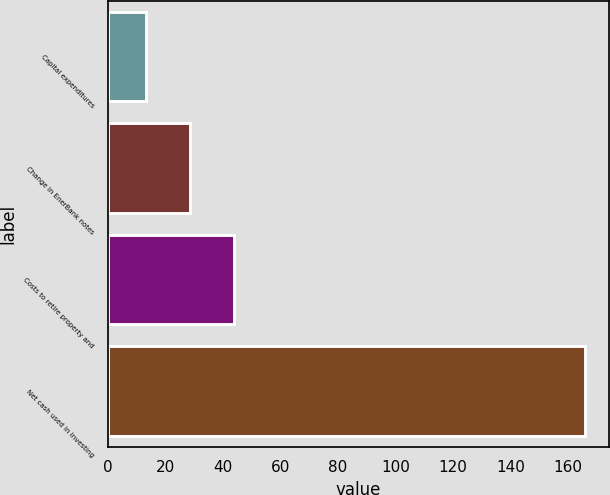Convert chart to OTSL. <chart><loc_0><loc_0><loc_500><loc_500><bar_chart><fcel>Capital expenditures<fcel>Change in EnerBank notes<fcel>Costs to retire property and<fcel>Net cash used in investing<nl><fcel>13<fcel>28.3<fcel>43.6<fcel>166<nl></chart> 